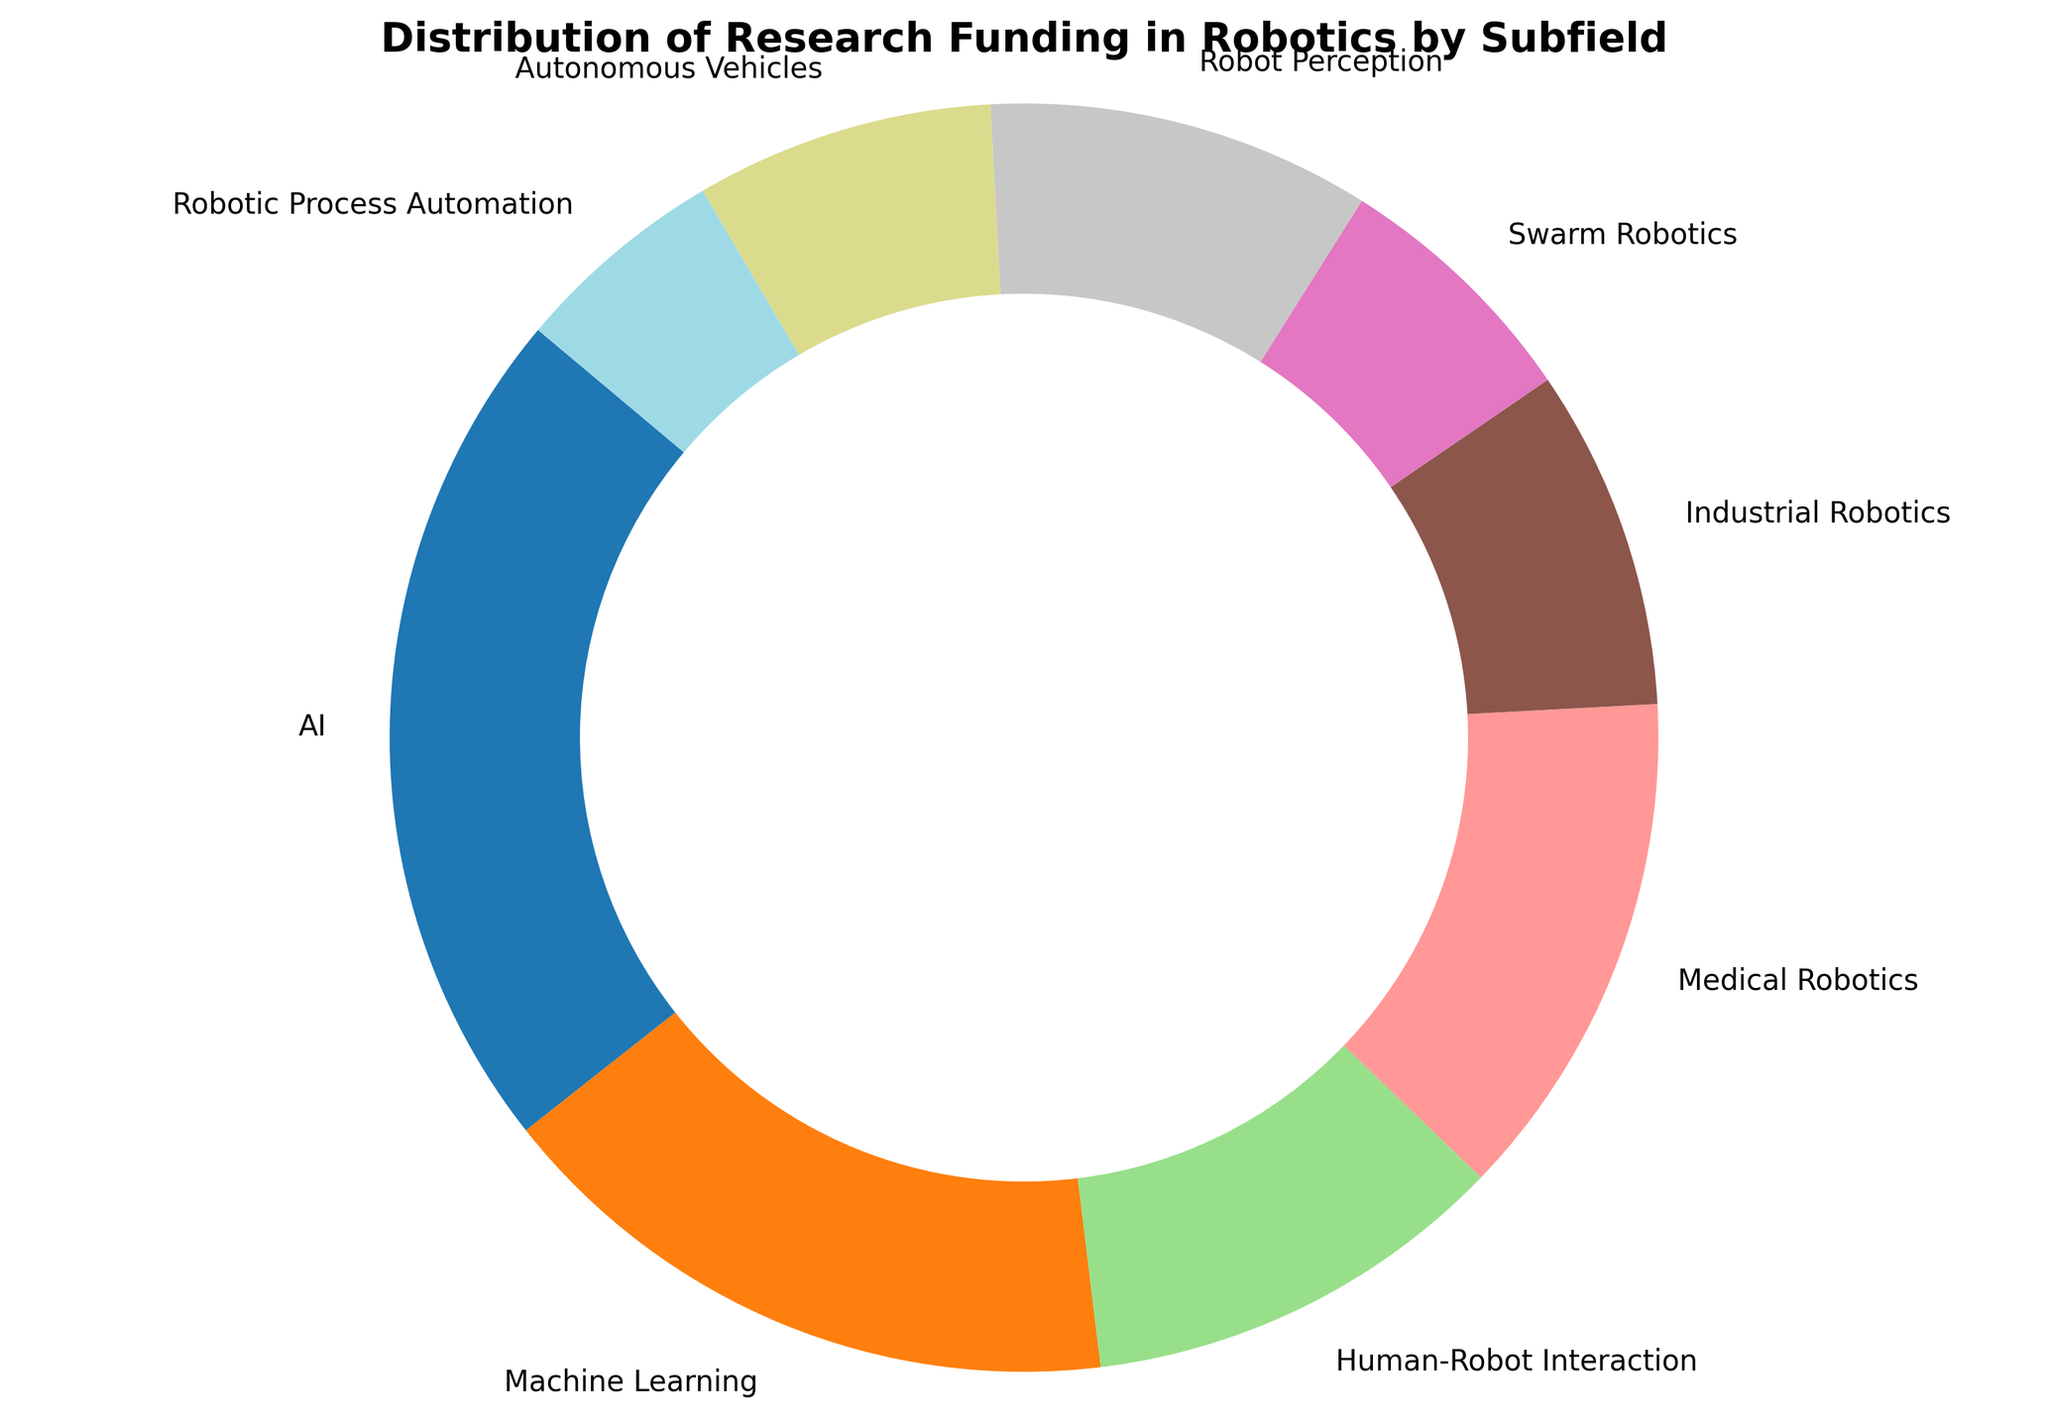What is the subfield with the largest share of research funding? The figure shows various subfields with different funding amounts represented by wedges in a ring chart. The wedge showing the largest percentage corresponds to AI.
Answer: AI Which subfield has the smallest share of research funding? By looking at the smallest wedge in the ring chart, the subfield with the smallest share is Robotic Process Automation.
Answer: Robotic Process Automation How much more funding does AI receive compared to Industrial Robotics? The figure shows AI receiving 20,000,000 and Industrial Robotics receiving 8,000,000. The difference is calculated as 20,000,000 - 8,000,000.
Answer: 12,000,000 Which subfield receives more funding, Human-Robot Interaction or Medical Robotics? By comparing the wedges of Human-Robot Interaction and Medical Robotics, Medical Robotics receives more funding.
Answer: Medical Robotics What is the total percentage of funding received by Machine Learning and Human-Robot Interaction combined? Machine Learning has 15,000,000, and Human-Robot Interaction has 10,000,000. The total is 25,000,000. Converting to percentage: (25,000,000 / 82,000,000) * 100 ≈ 30.5%.
Answer: 30.5% What is the percentage difference in funding between Robot Perception and Swarm Robotics? Robot Perception receives 9,000,000 and Swarm Robotics receives 6,000,000. The difference in funding is 3,000,000. Percentage difference: 3,000,000 / 82,000,000 * 100 ≈ 3.7%.
Answer: 3.7% Which subfield shares the same color in the ring chart? Each wedge in the ring chart typically has a distinct color to represent different subfields. There are no subfields with the same color.
Answer: None What is the total amount of funding for Human-Robot Interaction, Autonomous Vehicles, and Swarm Robotics? Summing up the funding: Human-Robot Interaction (10,000,000) + Autonomous Vehicles (7,000,000) + Swarm Robotics (6,000,000) = 23,000,000.
Answer: 23,000,000 Compare the funding amounts of Autonomous Vehicles and Robot Perception. Which one is higher? The figure shows Autonomous Vehicles receiving 7,000,000 and Robot Perception receiving 9,000,000. Robot Perception has the higher funding amount.
Answer: Robot Perception What percentage of the total funding does AI receive? AI receives 20,000,000. The total funding is 82,000,000. Calculating percentage: (20,000,000 / 82,000,000) * 100 ≈ 24.4%.
Answer: 24.4% 